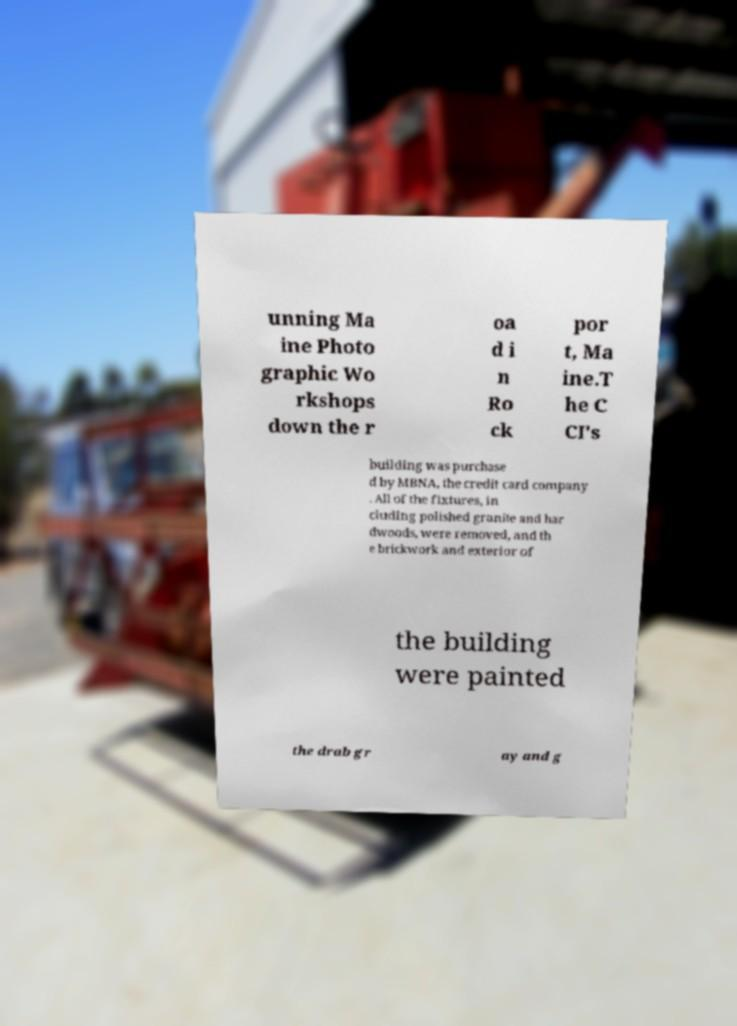What messages or text are displayed in this image? I need them in a readable, typed format. unning Ma ine Photo graphic Wo rkshops down the r oa d i n Ro ck por t, Ma ine.T he C CI's building was purchase d by MBNA, the credit card company . All of the fixtures, in cluding polished granite and har dwoods, were removed, and th e brickwork and exterior of the building were painted the drab gr ay and g 